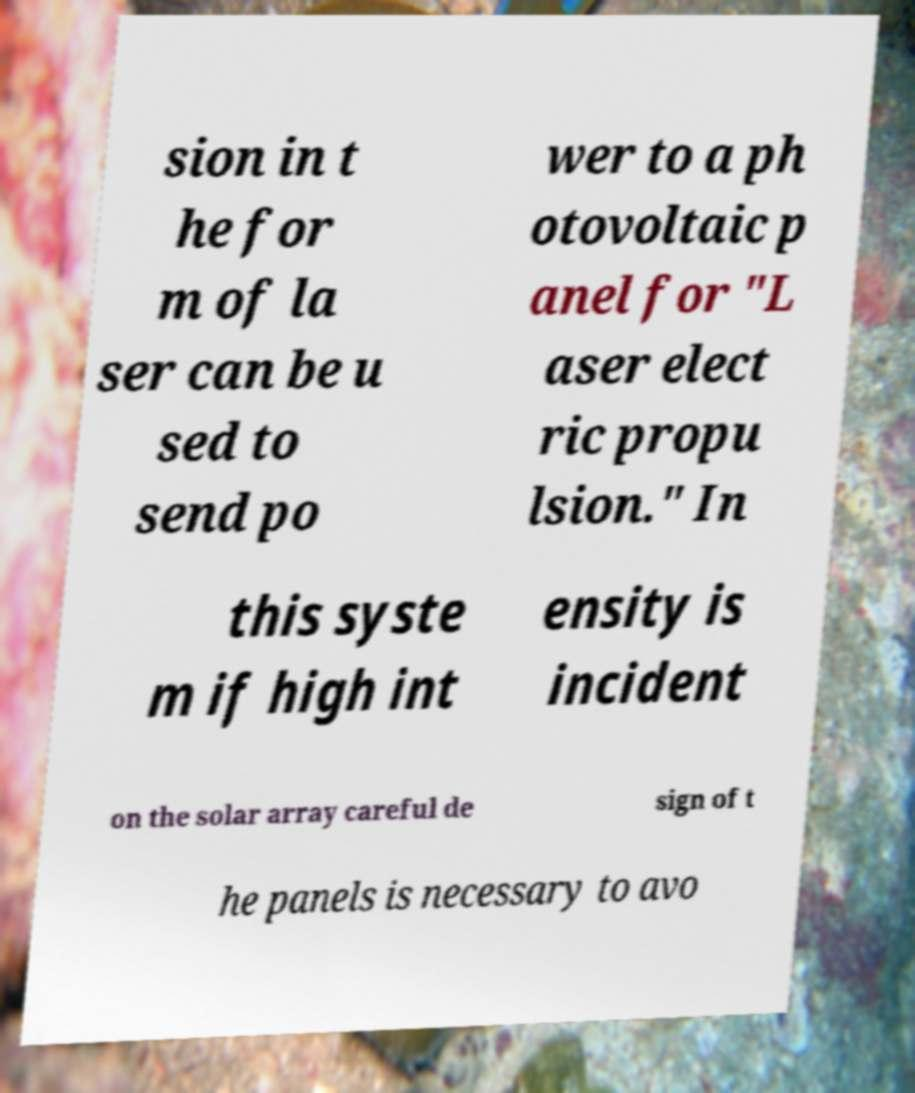Can you accurately transcribe the text from the provided image for me? sion in t he for m of la ser can be u sed to send po wer to a ph otovoltaic p anel for "L aser elect ric propu lsion." In this syste m if high int ensity is incident on the solar array careful de sign of t he panels is necessary to avo 